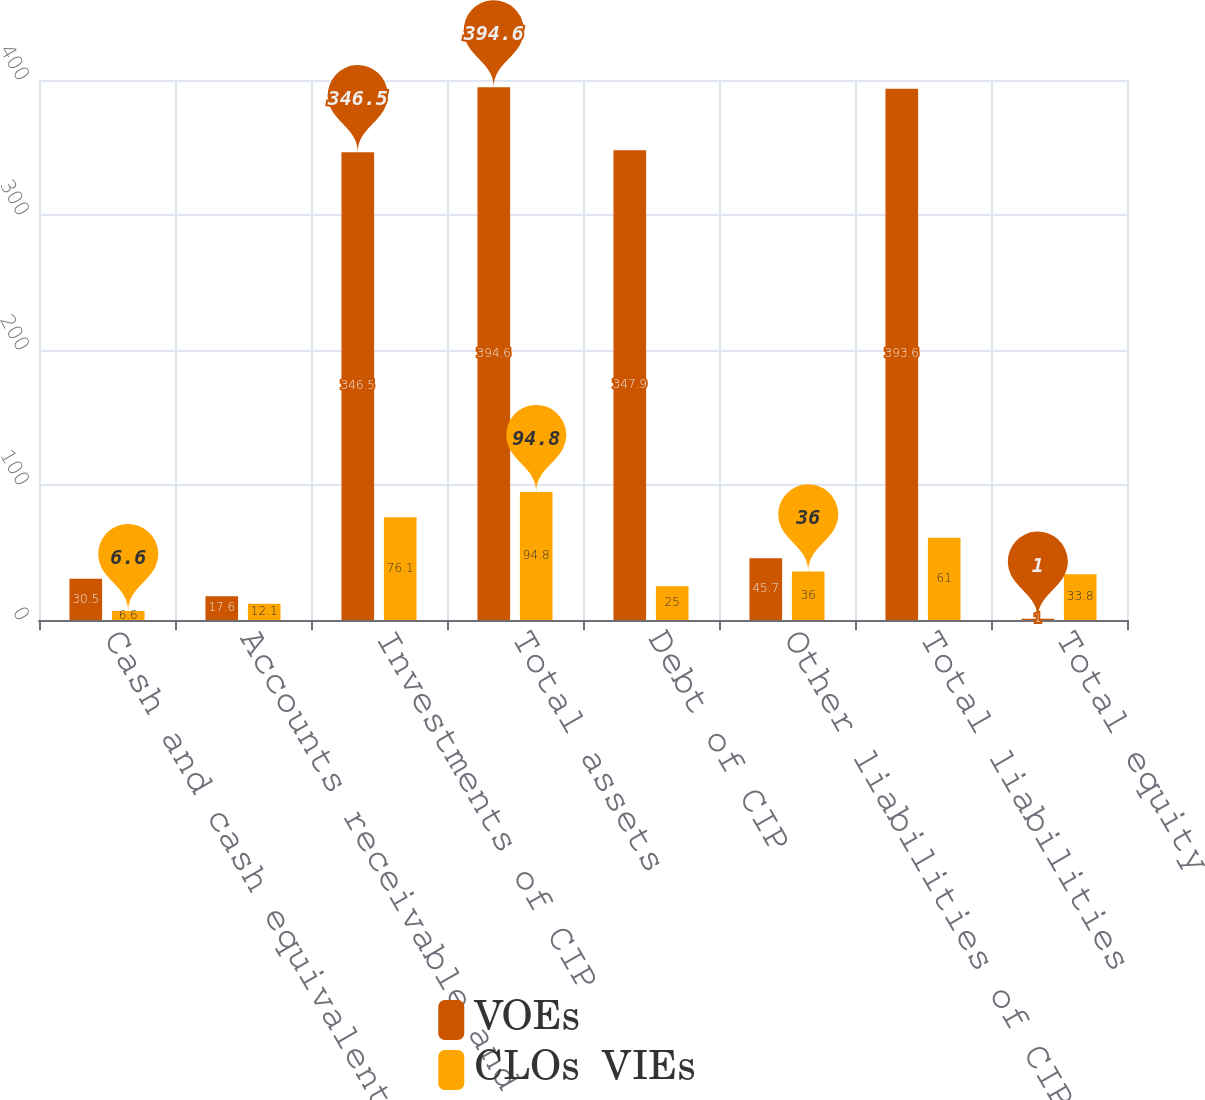<chart> <loc_0><loc_0><loc_500><loc_500><stacked_bar_chart><ecel><fcel>Cash and cash equivalents of<fcel>Accounts receivable and other<fcel>Investments of CIP<fcel>Total assets<fcel>Debt of CIP<fcel>Other liabilities of CIP<fcel>Total liabilities<fcel>Total equity<nl><fcel>VOEs<fcel>30.5<fcel>17.6<fcel>346.5<fcel>394.6<fcel>347.9<fcel>45.7<fcel>393.6<fcel>1<nl><fcel>CLOs  VIEs<fcel>6.6<fcel>12.1<fcel>76.1<fcel>94.8<fcel>25<fcel>36<fcel>61<fcel>33.8<nl></chart> 